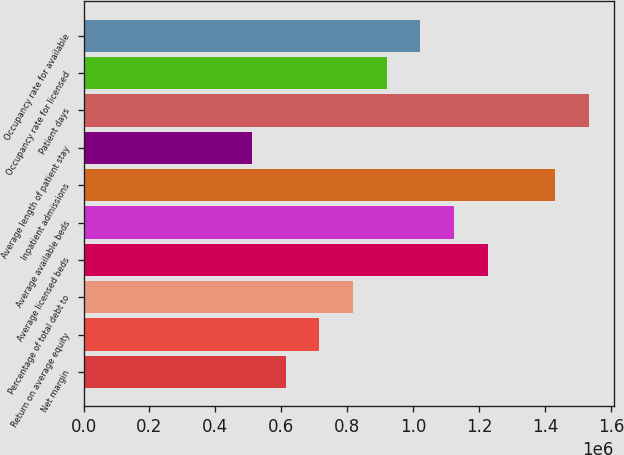<chart> <loc_0><loc_0><loc_500><loc_500><bar_chart><fcel>Net margin<fcel>Return on average equity<fcel>Percentage of total debt to<fcel>Average licensed beds<fcel>Average available beds<fcel>Inpatient admissions<fcel>Average length of patient stay<fcel>Patient days<fcel>Occupancy rate for licensed<fcel>Occupancy rate for available<nl><fcel>612490<fcel>714572<fcel>816654<fcel>1.22498e+06<fcel>1.1229e+06<fcel>1.42914e+06<fcel>510409<fcel>1.53123e+06<fcel>918735<fcel>1.02082e+06<nl></chart> 